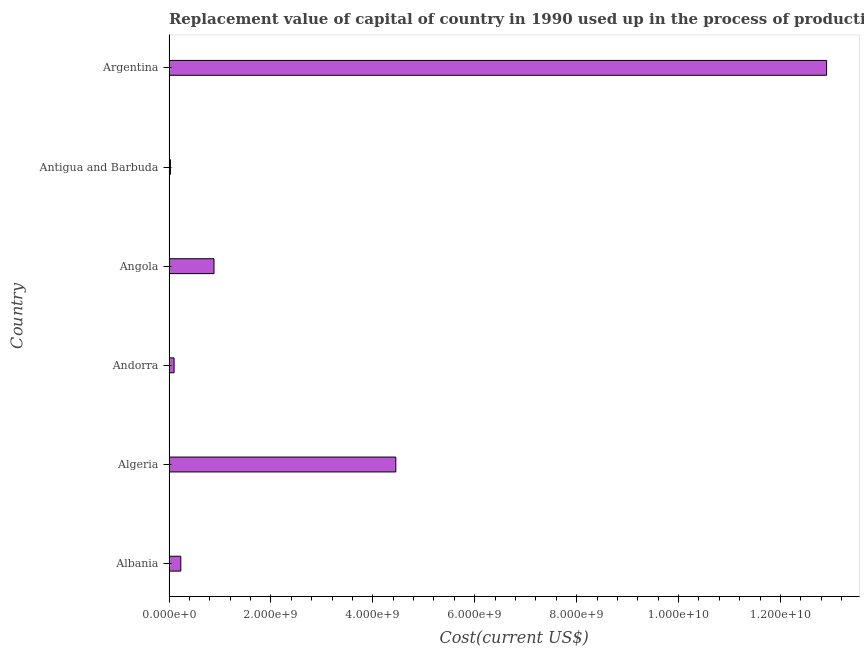What is the title of the graph?
Your answer should be very brief. Replacement value of capital of country in 1990 used up in the process of production. What is the label or title of the X-axis?
Give a very brief answer. Cost(current US$). What is the label or title of the Y-axis?
Offer a terse response. Country. What is the consumption of fixed capital in Antigua and Barbuda?
Provide a succinct answer. 2.78e+07. Across all countries, what is the maximum consumption of fixed capital?
Make the answer very short. 1.29e+1. Across all countries, what is the minimum consumption of fixed capital?
Your response must be concise. 2.78e+07. In which country was the consumption of fixed capital maximum?
Your answer should be very brief. Argentina. In which country was the consumption of fixed capital minimum?
Provide a short and direct response. Antigua and Barbuda. What is the sum of the consumption of fixed capital?
Provide a short and direct response. 1.86e+1. What is the difference between the consumption of fixed capital in Albania and Argentina?
Make the answer very short. -1.27e+1. What is the average consumption of fixed capital per country?
Give a very brief answer. 3.10e+09. What is the median consumption of fixed capital?
Keep it short and to the point. 5.58e+08. In how many countries, is the consumption of fixed capital greater than 10800000000 US$?
Your answer should be compact. 1. What is the ratio of the consumption of fixed capital in Angola to that in Argentina?
Provide a short and direct response. 0.07. Is the consumption of fixed capital in Albania less than that in Angola?
Your answer should be compact. Yes. Is the difference between the consumption of fixed capital in Algeria and Antigua and Barbuda greater than the difference between any two countries?
Offer a terse response. No. What is the difference between the highest and the second highest consumption of fixed capital?
Offer a very short reply. 8.45e+09. Is the sum of the consumption of fixed capital in Albania and Antigua and Barbuda greater than the maximum consumption of fixed capital across all countries?
Keep it short and to the point. No. What is the difference between the highest and the lowest consumption of fixed capital?
Your answer should be compact. 1.29e+1. In how many countries, is the consumption of fixed capital greater than the average consumption of fixed capital taken over all countries?
Offer a very short reply. 2. How many bars are there?
Your answer should be compact. 6. Are the values on the major ticks of X-axis written in scientific E-notation?
Your response must be concise. Yes. What is the Cost(current US$) in Albania?
Make the answer very short. 2.32e+08. What is the Cost(current US$) in Algeria?
Your answer should be compact. 4.45e+09. What is the Cost(current US$) of Andorra?
Offer a terse response. 9.99e+07. What is the Cost(current US$) in Angola?
Your answer should be very brief. 8.83e+08. What is the Cost(current US$) of Antigua and Barbuda?
Give a very brief answer. 2.78e+07. What is the Cost(current US$) of Argentina?
Your answer should be compact. 1.29e+1. What is the difference between the Cost(current US$) in Albania and Algeria?
Keep it short and to the point. -4.22e+09. What is the difference between the Cost(current US$) in Albania and Andorra?
Provide a short and direct response. 1.32e+08. What is the difference between the Cost(current US$) in Albania and Angola?
Your answer should be very brief. -6.51e+08. What is the difference between the Cost(current US$) in Albania and Antigua and Barbuda?
Offer a very short reply. 2.04e+08. What is the difference between the Cost(current US$) in Albania and Argentina?
Provide a succinct answer. -1.27e+1. What is the difference between the Cost(current US$) in Algeria and Andorra?
Keep it short and to the point. 4.35e+09. What is the difference between the Cost(current US$) in Algeria and Angola?
Your answer should be very brief. 3.57e+09. What is the difference between the Cost(current US$) in Algeria and Antigua and Barbuda?
Your answer should be very brief. 4.42e+09. What is the difference between the Cost(current US$) in Algeria and Argentina?
Provide a short and direct response. -8.45e+09. What is the difference between the Cost(current US$) in Andorra and Angola?
Offer a very short reply. -7.83e+08. What is the difference between the Cost(current US$) in Andorra and Antigua and Barbuda?
Keep it short and to the point. 7.21e+07. What is the difference between the Cost(current US$) in Andorra and Argentina?
Offer a terse response. -1.28e+1. What is the difference between the Cost(current US$) in Angola and Antigua and Barbuda?
Ensure brevity in your answer.  8.55e+08. What is the difference between the Cost(current US$) in Angola and Argentina?
Ensure brevity in your answer.  -1.20e+1. What is the difference between the Cost(current US$) in Antigua and Barbuda and Argentina?
Your response must be concise. -1.29e+1. What is the ratio of the Cost(current US$) in Albania to that in Algeria?
Ensure brevity in your answer.  0.05. What is the ratio of the Cost(current US$) in Albania to that in Andorra?
Your answer should be compact. 2.32. What is the ratio of the Cost(current US$) in Albania to that in Angola?
Keep it short and to the point. 0.26. What is the ratio of the Cost(current US$) in Albania to that in Antigua and Barbuda?
Keep it short and to the point. 8.35. What is the ratio of the Cost(current US$) in Albania to that in Argentina?
Provide a succinct answer. 0.02. What is the ratio of the Cost(current US$) in Algeria to that in Andorra?
Provide a succinct answer. 44.56. What is the ratio of the Cost(current US$) in Algeria to that in Angola?
Your response must be concise. 5.04. What is the ratio of the Cost(current US$) in Algeria to that in Antigua and Barbuda?
Offer a very short reply. 160.36. What is the ratio of the Cost(current US$) in Algeria to that in Argentina?
Offer a very short reply. 0.34. What is the ratio of the Cost(current US$) in Andorra to that in Angola?
Provide a succinct answer. 0.11. What is the ratio of the Cost(current US$) in Andorra to that in Antigua and Barbuda?
Your answer should be very brief. 3.6. What is the ratio of the Cost(current US$) in Andorra to that in Argentina?
Offer a very short reply. 0.01. What is the ratio of the Cost(current US$) in Angola to that in Antigua and Barbuda?
Give a very brief answer. 31.82. What is the ratio of the Cost(current US$) in Angola to that in Argentina?
Make the answer very short. 0.07. What is the ratio of the Cost(current US$) in Antigua and Barbuda to that in Argentina?
Offer a very short reply. 0. 